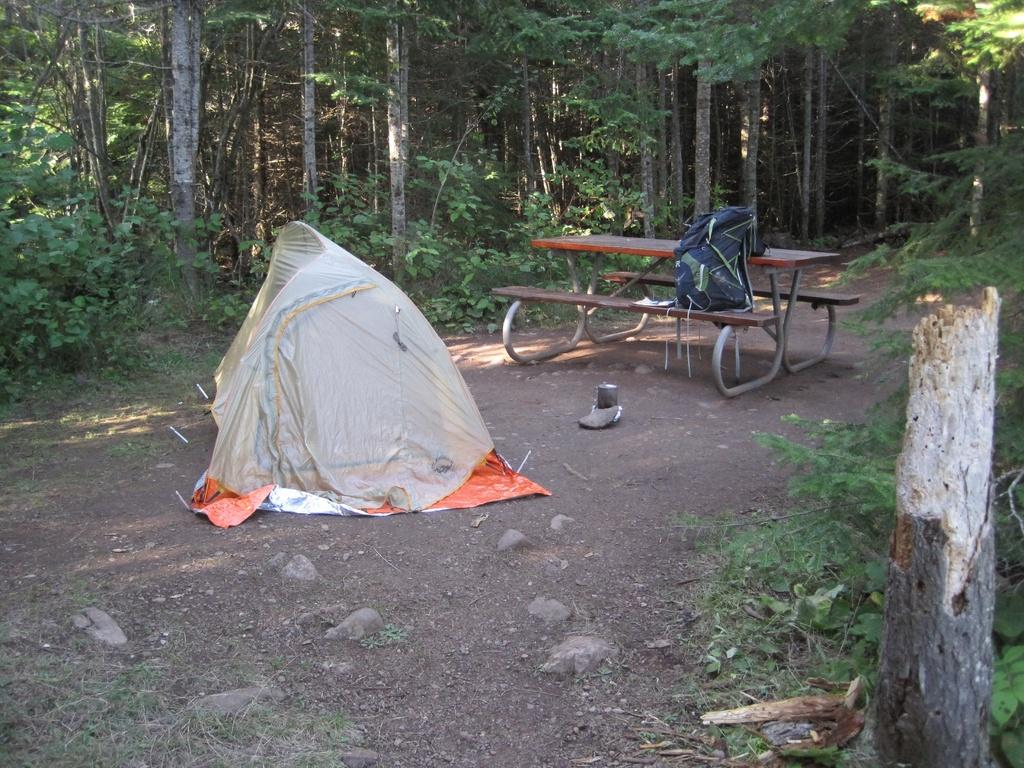What type of shelter is present in the image? There is a tent in the image. What type of seating is also visible in the image? There is a bench in the image. Where are the tent and bench located? The tent and bench are located in the middle of a forest. What type of vegetation can be seen in the image? There are trees visible in the image. How many pigs are visible in the image? There are no pigs present in the image. What type of vehicles can be seen driving up the hill in the image? There is no hill or vehicles present in the image. 